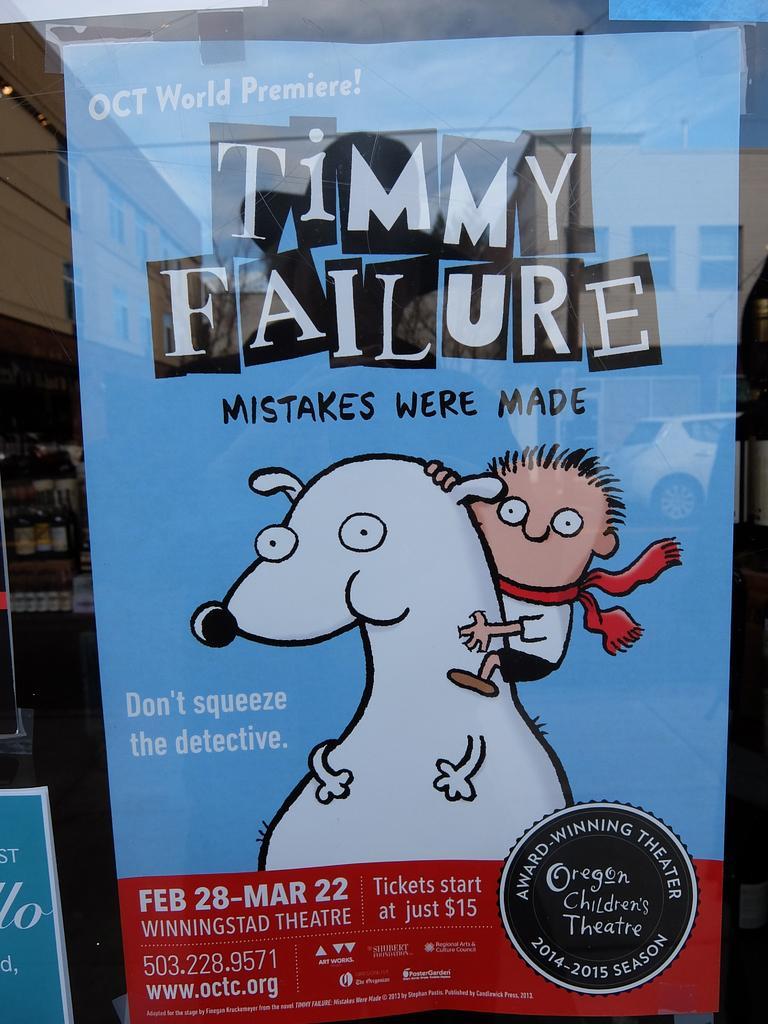In one or two sentences, can you explain what this image depicts? In this image we can see a poster which is in blue and red color, on the poster there is a some text, on the left side there are some bottles, on the right side there is a vehicle and in the background there is a building. 